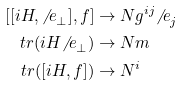<formula> <loc_0><loc_0><loc_500><loc_500>[ [ i H , { \not \, e } _ { \bot } ] , f ] & \rightarrow N { g } ^ { i j } { \not \, e } _ { j } \\ t r ( i H { \not \, e } _ { \bot } ) & \rightarrow N m \\ t r ( [ i H , f ] ) & \rightarrow { N } ^ { i }</formula> 